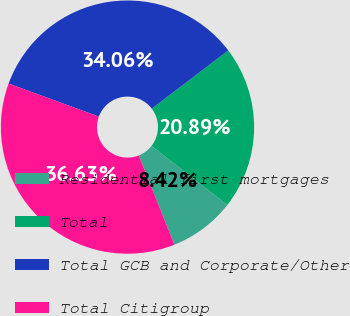<chart> <loc_0><loc_0><loc_500><loc_500><pie_chart><fcel>Residential first mortgages<fcel>Total<fcel>Total GCB and Corporate/Other<fcel>Total Citigroup<nl><fcel>8.42%<fcel>20.89%<fcel>34.06%<fcel>36.63%<nl></chart> 